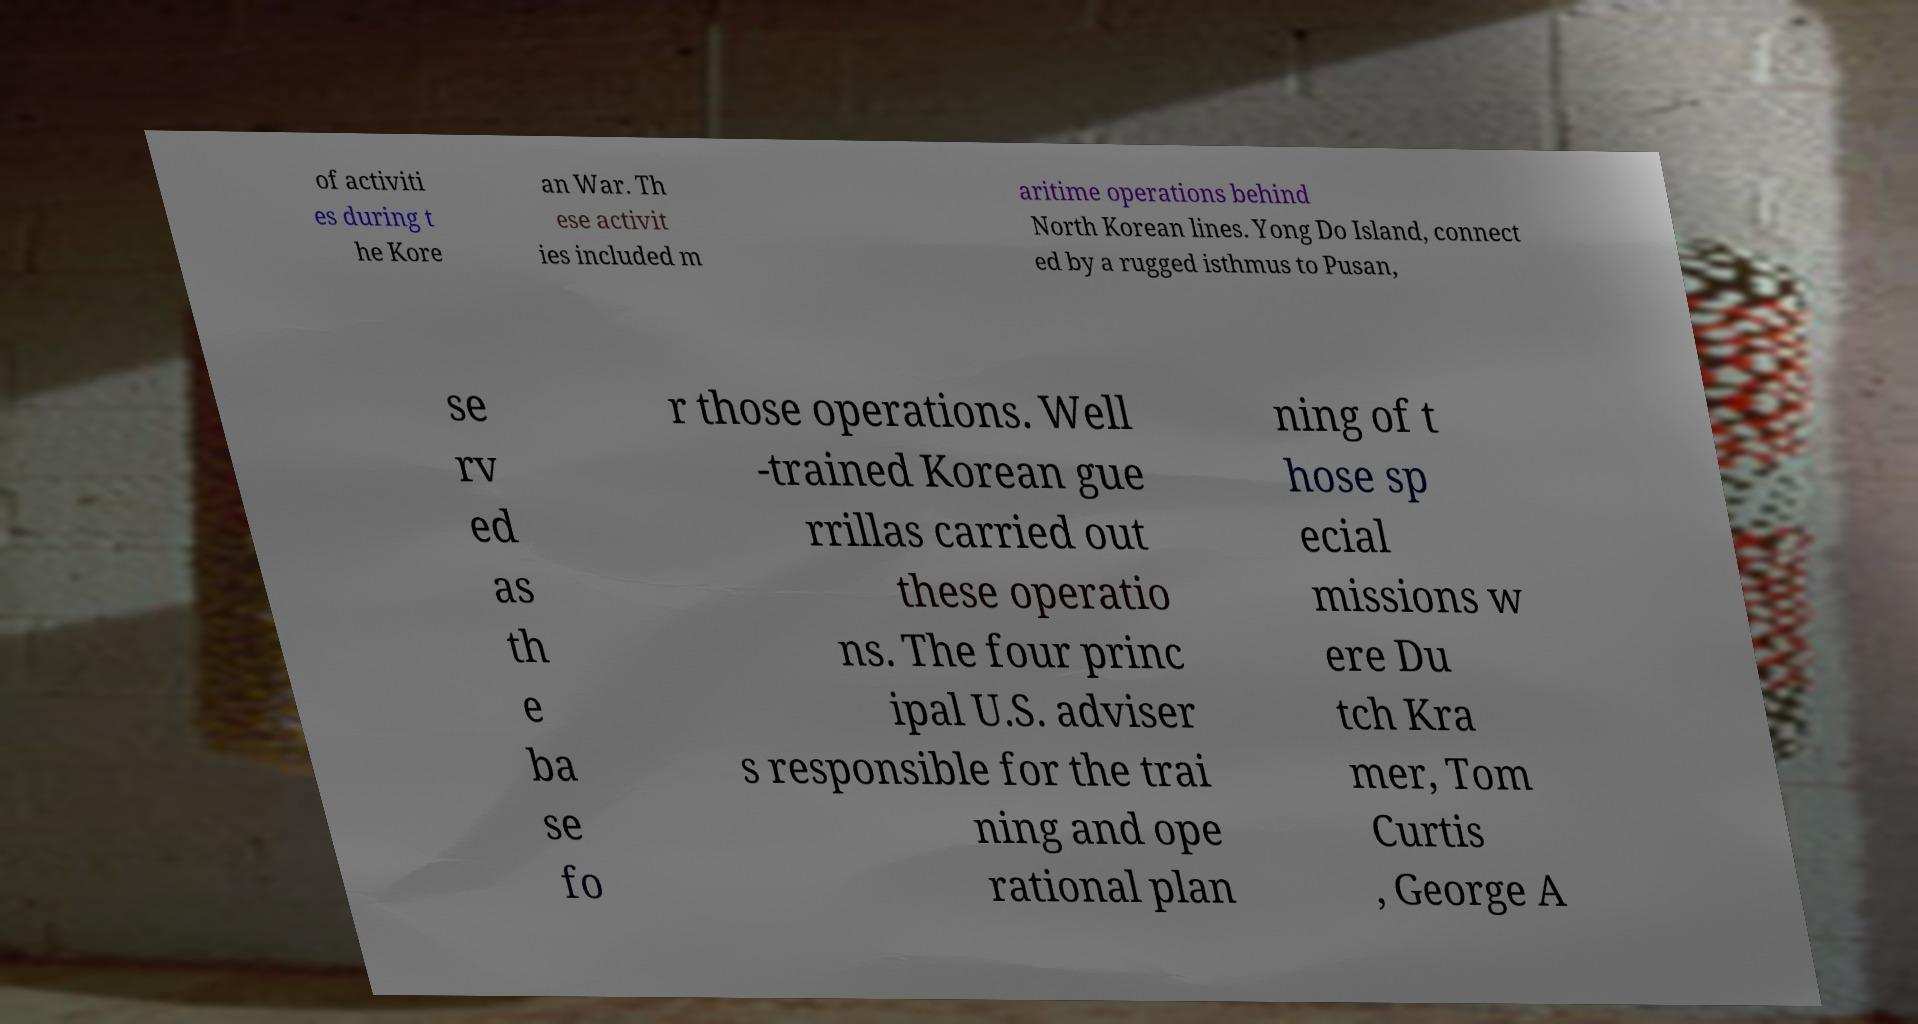Could you assist in decoding the text presented in this image and type it out clearly? of activiti es during t he Kore an War. Th ese activit ies included m aritime operations behind North Korean lines. Yong Do Island, connect ed by a rugged isthmus to Pusan, se rv ed as th e ba se fo r those operations. Well -trained Korean gue rrillas carried out these operatio ns. The four princ ipal U.S. adviser s responsible for the trai ning and ope rational plan ning of t hose sp ecial missions w ere Du tch Kra mer, Tom Curtis , George A 